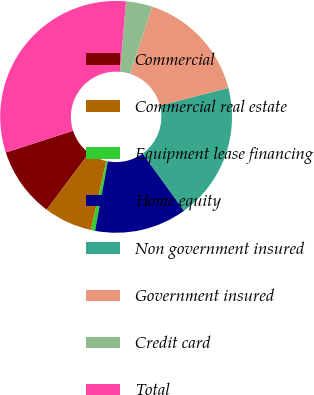Convert chart to OTSL. <chart><loc_0><loc_0><loc_500><loc_500><pie_chart><fcel>Commercial<fcel>Commercial real estate<fcel>Equipment lease financing<fcel>Home equity<fcel>Non government insured<fcel>Government insured<fcel>Credit card<fcel>Total<nl><fcel>9.81%<fcel>6.73%<fcel>0.58%<fcel>12.88%<fcel>19.04%<fcel>15.96%<fcel>3.66%<fcel>31.34%<nl></chart> 